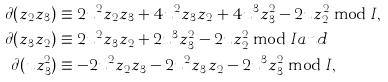<formula> <loc_0><loc_0><loc_500><loc_500>\partial ( z _ { 2 } z _ { 3 } ) & \equiv 2 u ^ { 2 } z _ { 2 } z _ { 3 } + 4 u ^ { 2 } z _ { 3 } z _ { 2 } + 4 u ^ { 3 } z _ { 3 } ^ { 2 } - 2 u z _ { 2 } ^ { 2 } \bmod I , \\ \partial ( z _ { 3 } z _ { 2 } ) & \equiv 2 u ^ { 2 } z _ { 3 } z _ { 2 } + 2 u ^ { 3 } z _ { 3 } ^ { 2 } - 2 u z _ { 2 } ^ { 2 } \bmod I a n d \\ \partial ( u z _ { 3 } ^ { 2 } ) & \equiv - 2 u ^ { 2 } z _ { 2 } z _ { 3 } - 2 u ^ { 2 } z _ { 3 } z _ { 2 } - 2 u ^ { 3 } z _ { 3 } ^ { 2 } \bmod I ,</formula> 